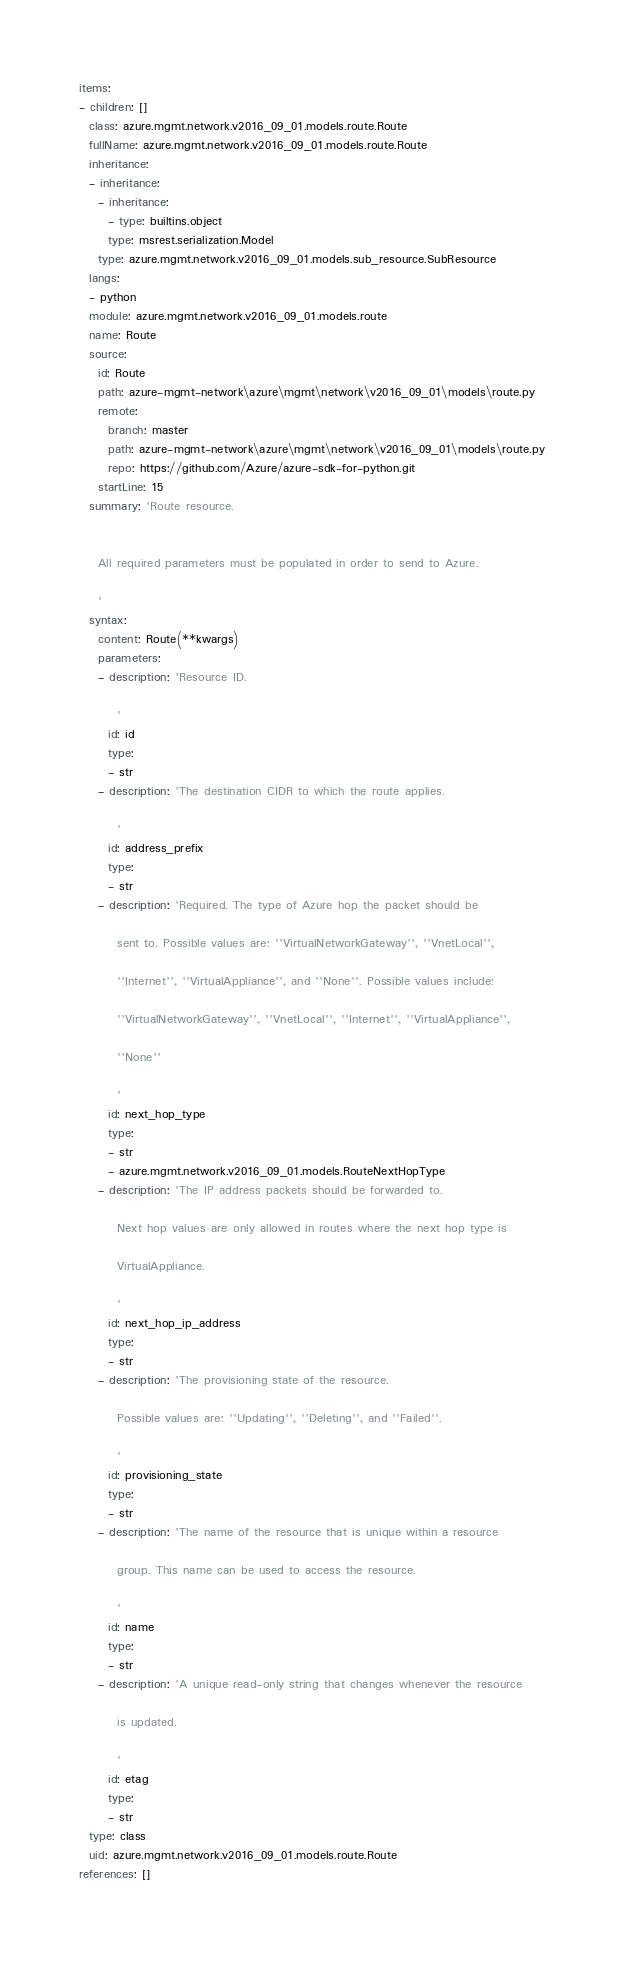<code> <loc_0><loc_0><loc_500><loc_500><_YAML_>items:
- children: []
  class: azure.mgmt.network.v2016_09_01.models.route.Route
  fullName: azure.mgmt.network.v2016_09_01.models.route.Route
  inheritance:
  - inheritance:
    - inheritance:
      - type: builtins.object
      type: msrest.serialization.Model
    type: azure.mgmt.network.v2016_09_01.models.sub_resource.SubResource
  langs:
  - python
  module: azure.mgmt.network.v2016_09_01.models.route
  name: Route
  source:
    id: Route
    path: azure-mgmt-network\azure\mgmt\network\v2016_09_01\models\route.py
    remote:
      branch: master
      path: azure-mgmt-network\azure\mgmt\network\v2016_09_01\models\route.py
      repo: https://github.com/Azure/azure-sdk-for-python.git
    startLine: 15
  summary: 'Route resource.


    All required parameters must be populated in order to send to Azure.

    '
  syntax:
    content: Route(**kwargs)
    parameters:
    - description: 'Resource ID.

        '
      id: id
      type:
      - str
    - description: 'The destination CIDR to which the route applies.

        '
      id: address_prefix
      type:
      - str
    - description: 'Required. The type of Azure hop the packet should be

        sent to. Possible values are: ''VirtualNetworkGateway'', ''VnetLocal'',

        ''Internet'', ''VirtualAppliance'', and ''None''. Possible values include:

        ''VirtualNetworkGateway'', ''VnetLocal'', ''Internet'', ''VirtualAppliance'',

        ''None''

        '
      id: next_hop_type
      type:
      - str
      - azure.mgmt.network.v2016_09_01.models.RouteNextHopType
    - description: 'The IP address packets should be forwarded to.

        Next hop values are only allowed in routes where the next hop type is

        VirtualAppliance.

        '
      id: next_hop_ip_address
      type:
      - str
    - description: 'The provisioning state of the resource.

        Possible values are: ''Updating'', ''Deleting'', and ''Failed''.

        '
      id: provisioning_state
      type:
      - str
    - description: 'The name of the resource that is unique within a resource

        group. This name can be used to access the resource.

        '
      id: name
      type:
      - str
    - description: 'A unique read-only string that changes whenever the resource

        is updated.

        '
      id: etag
      type:
      - str
  type: class
  uid: azure.mgmt.network.v2016_09_01.models.route.Route
references: []
</code> 